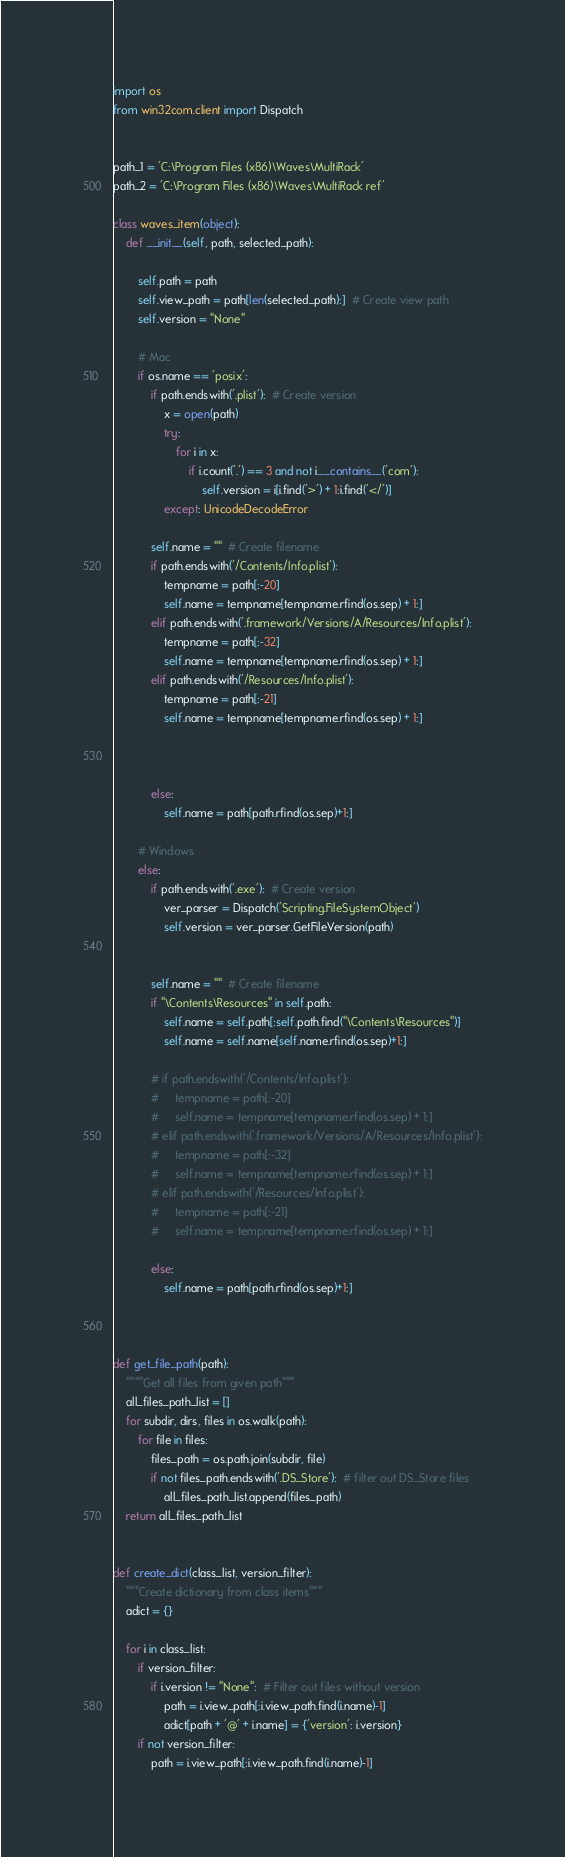Convert code to text. <code><loc_0><loc_0><loc_500><loc_500><_Python_>import os
from win32com.client import Dispatch


path_1 = 'C:\Program Files (x86)\Waves\MultiRack'
path_2 = 'C:\Program Files (x86)\Waves\MultiRack ref'

class waves_item(object):
    def __init__(self, path, selected_path):

        self.path = path
        self.view_path = path[len(selected_path):]  # Create view path
        self.version = "None"

        # Mac
        if os.name == 'posix':
            if path.endswith('.plist'):  # Create version
                x = open(path)
                try:
                    for i in x:
                        if i.count('.') == 3 and not i.__contains__('com'):
                            self.version = i[i.find('>') + 1:i.find('</')]
                except: UnicodeDecodeError

            self.name = ""  # Create filename
            if path.endswith('/Contents/Info.plist'):
                tempname = path[:-20]
                self.name = tempname[tempname.rfind(os.sep) + 1:]
            elif path.endswith('.framework/Versions/A/Resources/Info.plist'):
                tempname = path[:-32]
                self.name = tempname[tempname.rfind(os.sep) + 1:]
            elif path.endswith('/Resources/Info.plist'):
                tempname = path[:-21]
                self.name = tempname[tempname.rfind(os.sep) + 1:]



            else:
                self.name = path[path.rfind(os.sep)+1:]

        # Windows
        else:
            if path.endswith('.exe'):  # Create version
                ver_parser = Dispatch('Scripting.FileSystemObject')
                self.version = ver_parser.GetFileVersion(path)


            self.name = ""  # Create filename
            if "\Contents\Resources" in self.path:
                self.name = self.path[:self.path.find("\Contents\Resources")]
                self.name = self.name[self.name.rfind(os.sep)+1:]

            # if path.endswith('/Contents/Info.plist'):
            #     tempname = path[:-20]
            #     self.name = tempname[tempname.rfind(os.sep) + 1:]
            # elif path.endswith('.framework/Versions/A/Resources/Info.plist'):
            #     tempname = path[:-32]
            #     self.name = tempname[tempname.rfind(os.sep) + 1:]
            # elif path.endswith('/Resources/Info.plist'):
            #     tempname = path[:-21]
            #     self.name = tempname[tempname.rfind(os.sep) + 1:]

            else:
                self.name = path[path.rfind(os.sep)+1:]



def get_file_path(path):
    """"Get all files from given path"""
    all_files_path_list = []
    for subdir, dirs, files in os.walk(path):
        for file in files:
            files_path = os.path.join(subdir, file)
            if not files_path.endswith('.DS_Store'):  # filter out DS_Store files
                all_files_path_list.append(files_path)
    return all_files_path_list


def create_dict(class_list, version_filter):
    """Create dictionary from class items"""
    adict = {}

    for i in class_list:
        if version_filter:
            if i.version != "None":  # Filter out files without version
                path = i.view_path[:i.view_path.find(i.name)-1]
                adict[path + '@' + i.name] = {'version': i.version}
        if not version_filter:
            path = i.view_path[:i.view_path.find(i.name)-1]</code> 